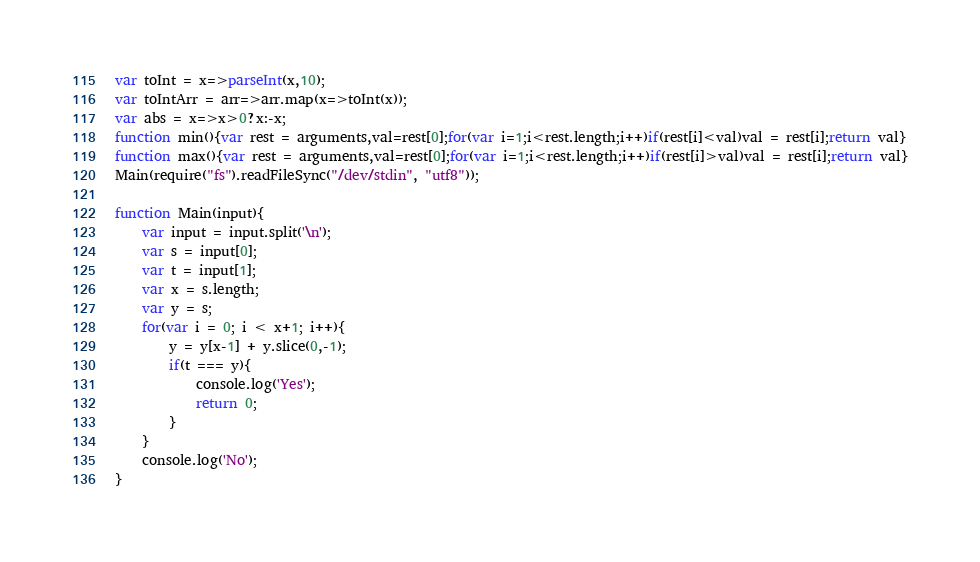<code> <loc_0><loc_0><loc_500><loc_500><_JavaScript_>var toInt = x=>parseInt(x,10);
var toIntArr = arr=>arr.map(x=>toInt(x));
var abs = x=>x>0?x:-x;
function min(){var rest = arguments,val=rest[0];for(var i=1;i<rest.length;i++)if(rest[i]<val)val = rest[i];return val}
function max(){var rest = arguments,val=rest[0];for(var i=1;i<rest.length;i++)if(rest[i]>val)val = rest[i];return val}
Main(require("fs").readFileSync("/dev/stdin", "utf8"));
 
function Main(input){
	var input = input.split('\n');
	var s = input[0];
	var t = input[1];
	var x = s.length;
	var y = s;
	for(var i = 0; i < x+1; i++){
		y = y[x-1] + y.slice(0,-1);
		if(t === y){
			console.log('Yes');
			return 0;
		}
	}
	console.log('No');	
}</code> 